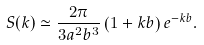<formula> <loc_0><loc_0><loc_500><loc_500>S ( { k } ) \simeq \frac { 2 \pi } { 3 a ^ { 2 } b ^ { 3 } } \left ( 1 + k b \right ) e ^ { - k b } .</formula> 